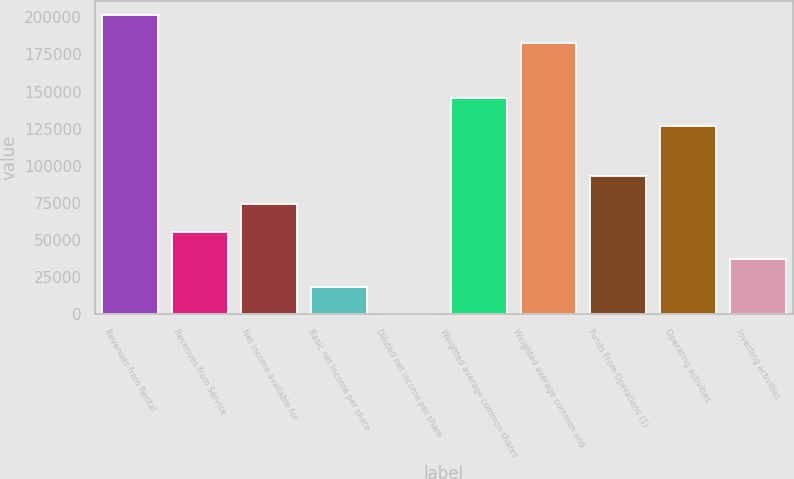<chart> <loc_0><loc_0><loc_500><loc_500><bar_chart><fcel>Revenues from Rental<fcel>Revenues from Service<fcel>Net income available for<fcel>Basic net income per share<fcel>Diluted net income per share<fcel>Weighted average common shares<fcel>Weighted average common and<fcel>Funds From Operations (1)<fcel>Operating activities<fcel>Investing activities<nl><fcel>201217<fcel>55728.2<fcel>74304.2<fcel>18576.3<fcel>0.35<fcel>145489<fcel>182641<fcel>92880.2<fcel>126913<fcel>37152.3<nl></chart> 